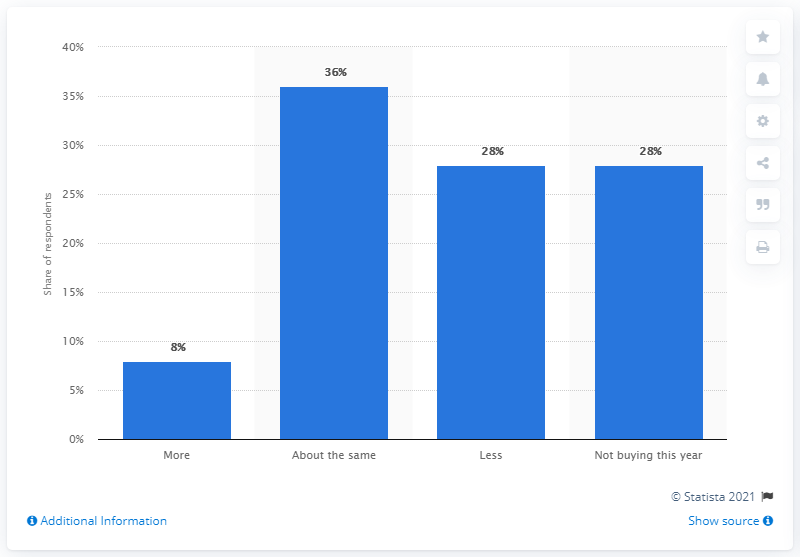Point out several critical features in this image. Approximately 36 people spent the same amount as they did last year. The average of less and not buying this year is 28. 